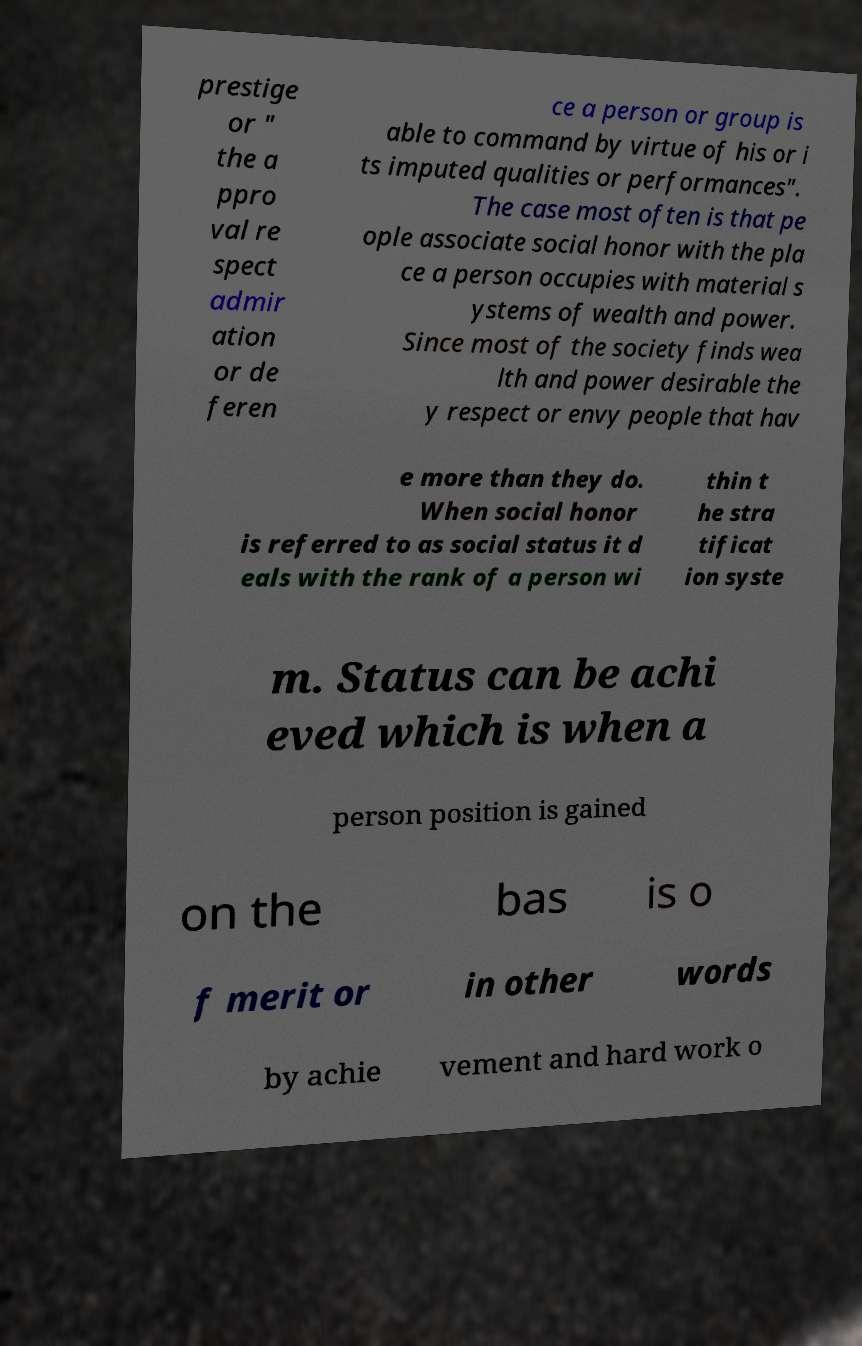There's text embedded in this image that I need extracted. Can you transcribe it verbatim? prestige or " the a ppro val re spect admir ation or de feren ce a person or group is able to command by virtue of his or i ts imputed qualities or performances". The case most often is that pe ople associate social honor with the pla ce a person occupies with material s ystems of wealth and power. Since most of the society finds wea lth and power desirable the y respect or envy people that hav e more than they do. When social honor is referred to as social status it d eals with the rank of a person wi thin t he stra tificat ion syste m. Status can be achi eved which is when a person position is gained on the bas is o f merit or in other words by achie vement and hard work o 